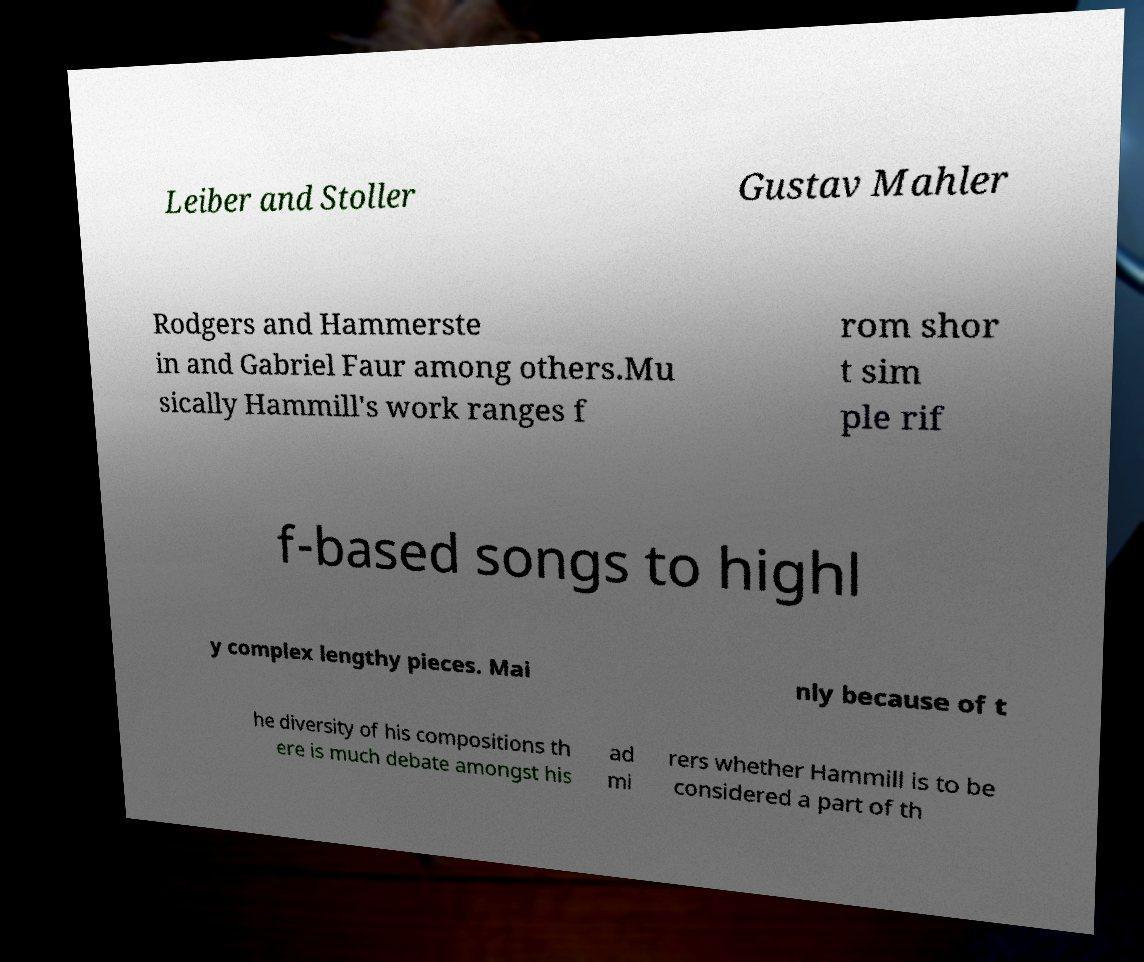What messages or text are displayed in this image? I need them in a readable, typed format. Leiber and Stoller Gustav Mahler Rodgers and Hammerste in and Gabriel Faur among others.Mu sically Hammill's work ranges f rom shor t sim ple rif f-based songs to highl y complex lengthy pieces. Mai nly because of t he diversity of his compositions th ere is much debate amongst his ad mi rers whether Hammill is to be considered a part of th 